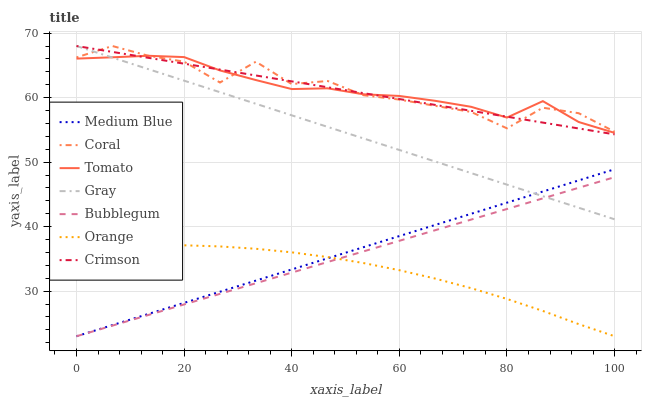Does Orange have the minimum area under the curve?
Answer yes or no. Yes. Does Coral have the maximum area under the curve?
Answer yes or no. Yes. Does Gray have the minimum area under the curve?
Answer yes or no. No. Does Gray have the maximum area under the curve?
Answer yes or no. No. Is Medium Blue the smoothest?
Answer yes or no. Yes. Is Coral the roughest?
Answer yes or no. Yes. Is Gray the smoothest?
Answer yes or no. No. Is Gray the roughest?
Answer yes or no. No. Does Medium Blue have the lowest value?
Answer yes or no. Yes. Does Gray have the lowest value?
Answer yes or no. No. Does Crimson have the highest value?
Answer yes or no. Yes. Does Medium Blue have the highest value?
Answer yes or no. No. Is Bubblegum less than Tomato?
Answer yes or no. Yes. Is Coral greater than Bubblegum?
Answer yes or no. Yes. Does Gray intersect Crimson?
Answer yes or no. Yes. Is Gray less than Crimson?
Answer yes or no. No. Is Gray greater than Crimson?
Answer yes or no. No. Does Bubblegum intersect Tomato?
Answer yes or no. No. 